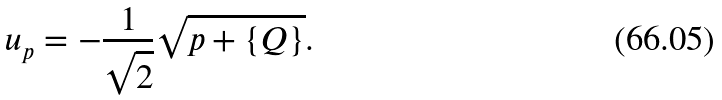Convert formula to latex. <formula><loc_0><loc_0><loc_500><loc_500>u _ { p } = - \frac { 1 } { \sqrt { 2 } } \sqrt { p + \{ Q \} } .</formula> 